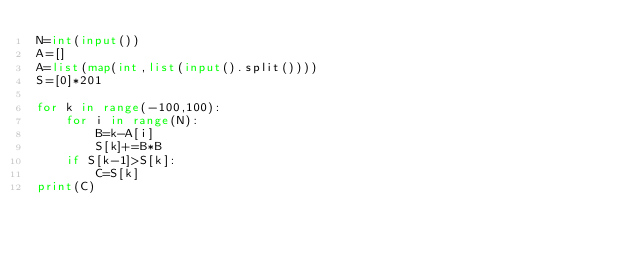Convert code to text. <code><loc_0><loc_0><loc_500><loc_500><_Python_>N=int(input())
A=[]
A=list(map(int,list(input().split())))
S=[0]*201

for k in range(-100,100):
    for i in range(N):
        B=k-A[i]
        S[k]+=B*B
    if S[k-1]>S[k]:
        C=S[k]
print(C)</code> 